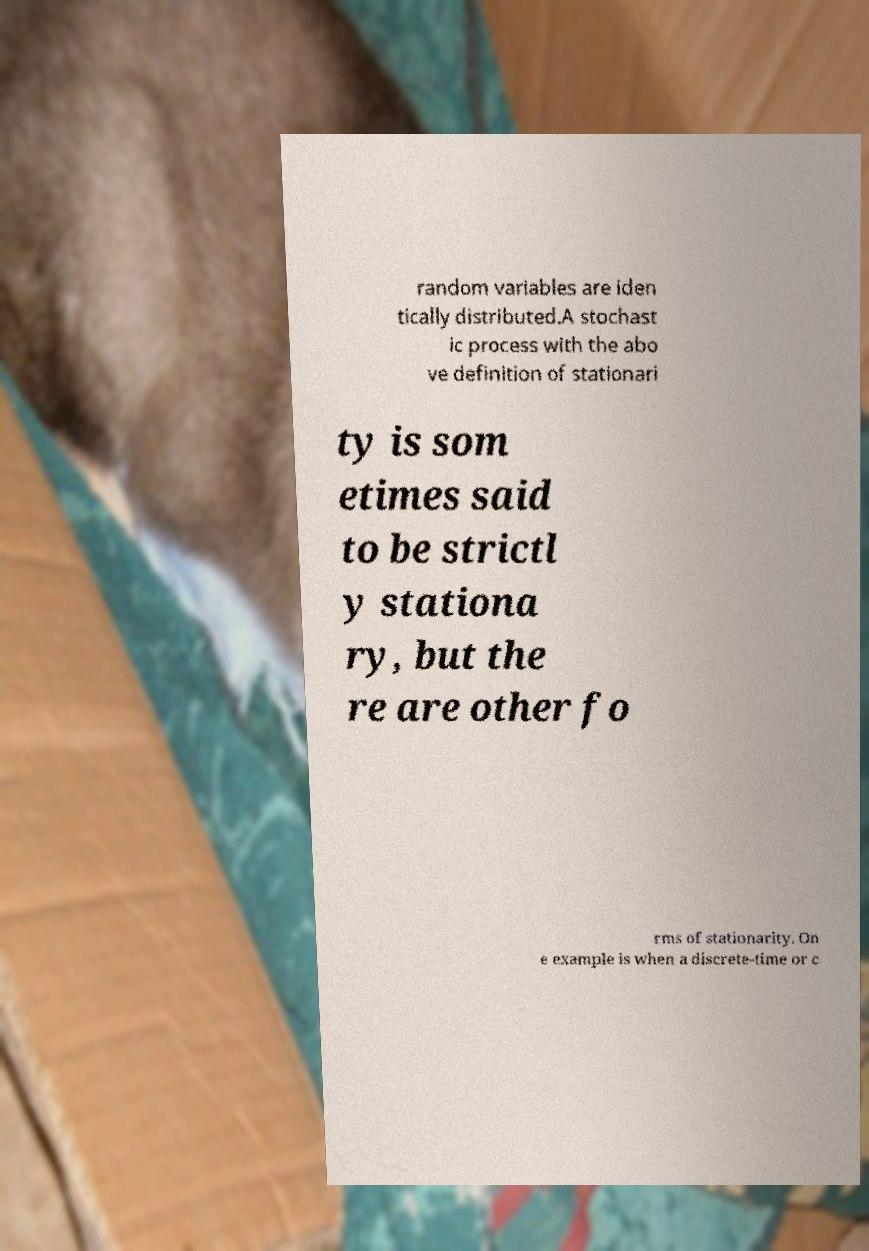Could you assist in decoding the text presented in this image and type it out clearly? random variables are iden tically distributed.A stochast ic process with the abo ve definition of stationari ty is som etimes said to be strictl y stationa ry, but the re are other fo rms of stationarity. On e example is when a discrete-time or c 